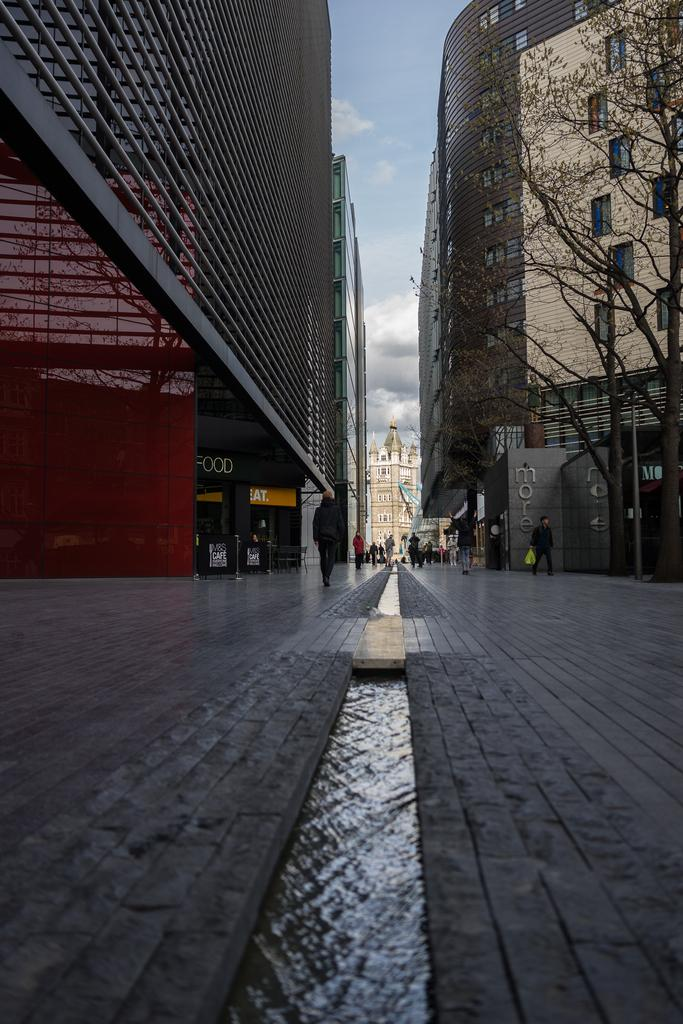<image>
Write a terse but informative summary of the picture. A sign that says FOOD is just one door down from a sign that says EAT. 